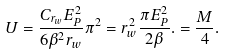Convert formula to latex. <formula><loc_0><loc_0><loc_500><loc_500>U = \frac { C _ { r _ { w } } E _ { P } ^ { 2 } } { 6 \beta ^ { 2 } r _ { w } } \pi ^ { 2 } = r _ { w } ^ { 2 } \frac { \pi E _ { P } ^ { 2 } } { 2 \beta } . = \frac { M } { 4 } .</formula> 